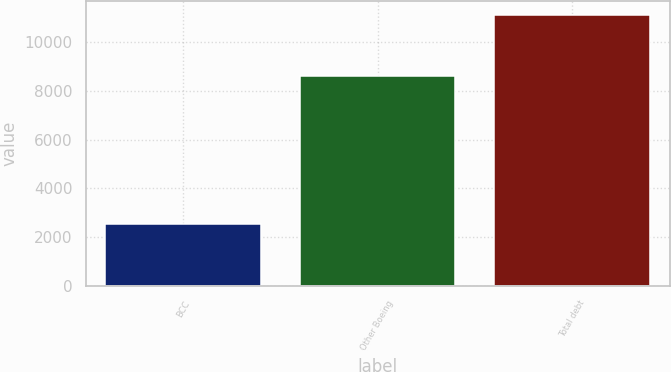<chart> <loc_0><loc_0><loc_500><loc_500><bar_chart><fcel>BCC<fcel>Other Boeing<fcel>Total debt<nl><fcel>2523<fcel>8594<fcel>11117<nl></chart> 